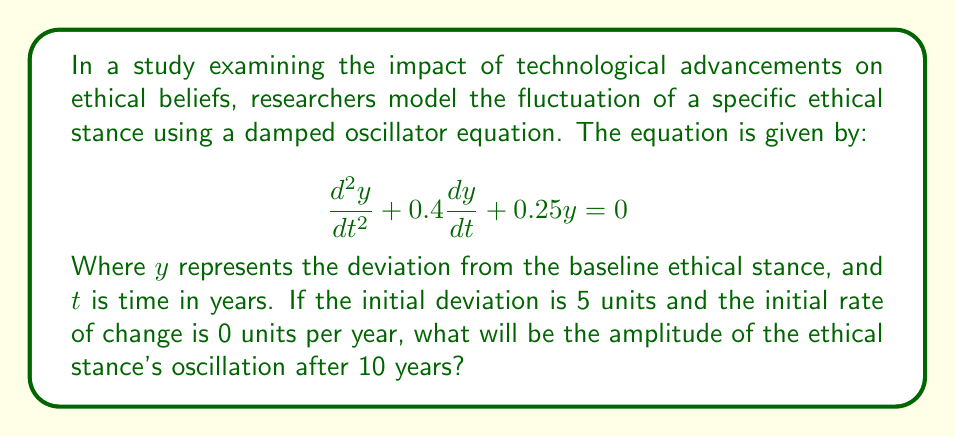Give your solution to this math problem. To solve this problem, we need to follow these steps:

1) First, we identify this as a second-order linear homogeneous differential equation with constant coefficients. The general form is:

   $$\frac{d^2y}{dt^2} + 2\zeta\omega_n\frac{dy}{dt} + \omega_n^2y = 0$$

   Where $\zeta$ is the damping ratio and $\omega_n$ is the natural frequency.

2) Comparing our equation to the general form, we can see that:
   
   $2\zeta\omega_n = 0.4$ and $\omega_n^2 = 0.25$

3) From $\omega_n^2 = 0.25$, we can deduce that $\omega_n = 0.5$.

4) Substituting this back into $2\zeta\omega_n = 0.4$, we get:
   
   $2\zeta(0.5) = 0.4$
   $\zeta = 0.4$

5) Since $0 < \zeta < 1$, this is an underdamped system. The solution for an underdamped system is:

   $$y(t) = Ae^{-\zeta\omega_n t}\cos(\omega_d t - \phi)$$

   Where $A$ is the amplitude, $\omega_d = \omega_n\sqrt{1-\zeta^2}$ is the damped natural frequency, and $\phi$ is the phase angle.

6) Calculate $\omega_d$:
   
   $$\omega_d = 0.5\sqrt{1-0.4^2} = 0.458$$

7) The amplitude $A$ decays according to $Ae^{-\zeta\omega_n t}$. After 10 years, the amplitude will be:

   $$A_{10} = Ae^{-0.4(0.5)(10)} = Ae^{-2} \approx 0.135A$$

8) To find $A$, we use the initial conditions. At $t=0$, $y(0) = 5$ and $y'(0) = 0$.

   From $y(0) = 5$, we can deduce that $A = 5$.

9) Therefore, after 10 years, the amplitude will be:

   $$A_{10} = 5e^{-2} \approx 0.677$$
Answer: The amplitude of the ethical stance's oscillation after 10 years will be approximately 0.677 units. 